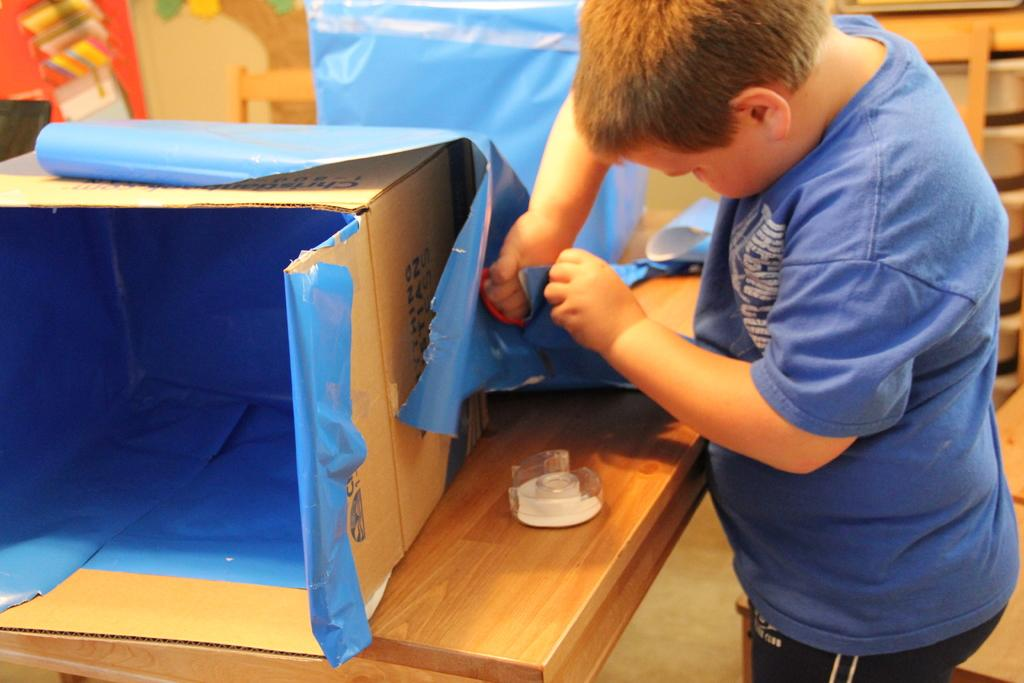Who is in the image? There is a boy in the image. What is the boy wearing? The boy is wearing a blue T-shirt and trousers. What objects can be seen on the table in the image? There is a box and a paper on the table in the image. Is there any furniture in the image? Yes, there is a table in the image. What type of bait is the boy using to catch fish in the image? There is no indication of fishing or bait in the image; it features a boy wearing a blue T-shirt and trousers, standing near a table with a box and a paper on it. What punishment is the boy receiving for his actions in the image? There is no indication of punishment or wrongdoing in the image; it simply shows a boy standing near a table with a box and a paper on it. 